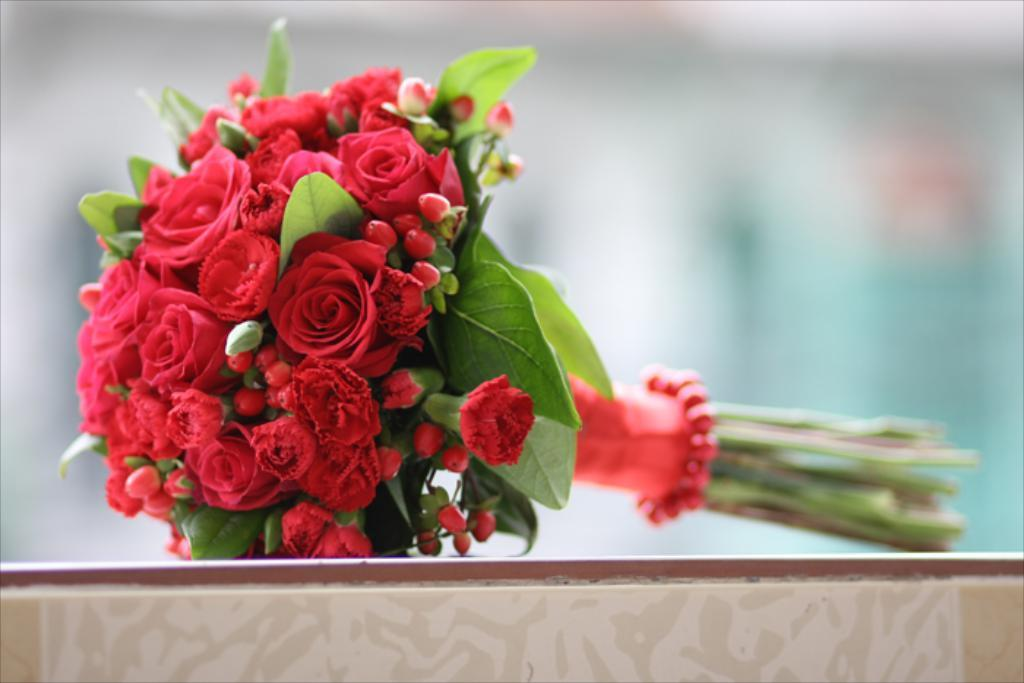What is the main subject of the image? The main subject of the image is a bouquet. What can be observed about the flowers in the bouquet? The bouquet contains red color flowers. What type of soap is used to clean the flowers in the image? There is no soap present in the image, and the flowers are not being cleaned. 